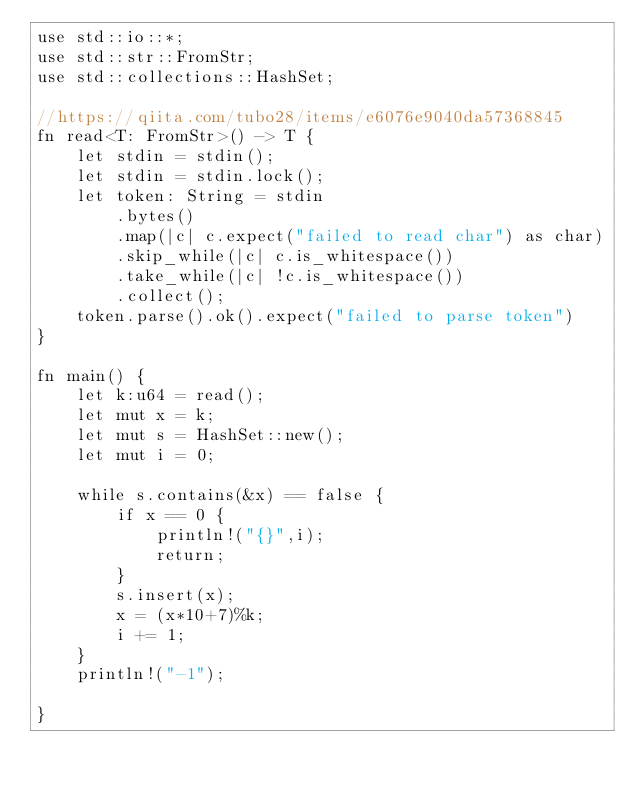<code> <loc_0><loc_0><loc_500><loc_500><_Rust_>use std::io::*;
use std::str::FromStr;
use std::collections::HashSet;

//https://qiita.com/tubo28/items/e6076e9040da57368845
fn read<T: FromStr>() -> T {
    let stdin = stdin();
    let stdin = stdin.lock();
    let token: String = stdin
        .bytes()
        .map(|c| c.expect("failed to read char") as char)
        .skip_while(|c| c.is_whitespace())
        .take_while(|c| !c.is_whitespace())
        .collect();
    token.parse().ok().expect("failed to parse token")
}

fn main() {
    let k:u64 = read();
    let mut x = k;
    let mut s = HashSet::new();
    let mut i = 0;

    while s.contains(&x) == false {
        if x == 0 {
            println!("{}",i);
            return;
        }
        s.insert(x);
        x = (x*10+7)%k;
        i += 1;
    }
    println!("-1");

}
</code> 